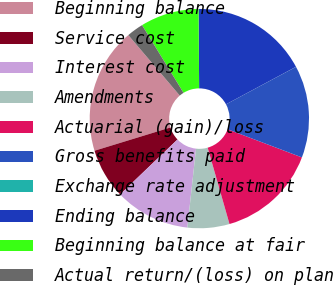Convert chart. <chart><loc_0><loc_0><loc_500><loc_500><pie_chart><fcel>Beginning balance<fcel>Service cost<fcel>Interest cost<fcel>Amendments<fcel>Actuarial (gain)/loss<fcel>Gross benefits paid<fcel>Exchange rate adjustment<fcel>Ending balance<fcel>Beginning balance at fair<fcel>Actual return/(loss) on plan<nl><fcel>18.51%<fcel>7.41%<fcel>11.11%<fcel>6.18%<fcel>14.81%<fcel>13.58%<fcel>0.01%<fcel>17.28%<fcel>8.64%<fcel>2.47%<nl></chart> 